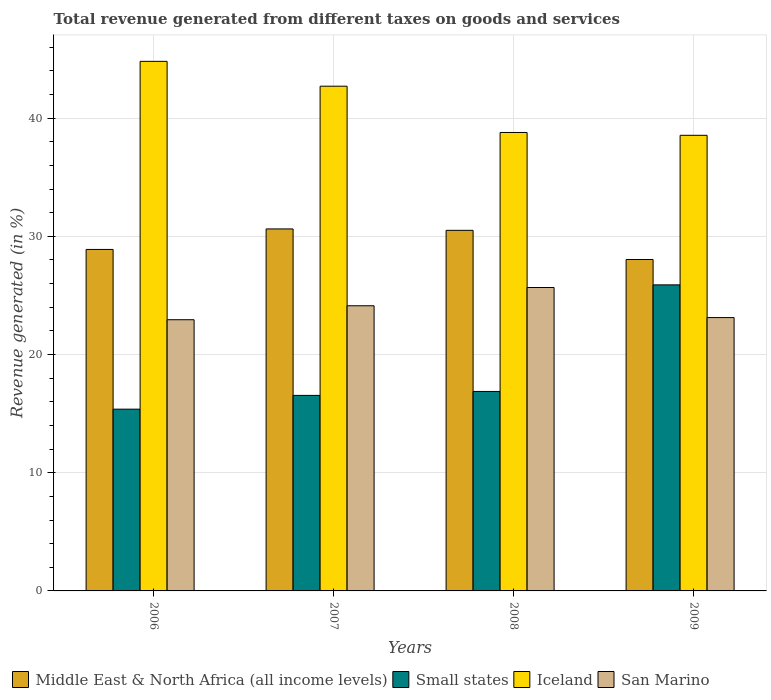How many different coloured bars are there?
Your response must be concise. 4. How many groups of bars are there?
Your answer should be very brief. 4. Are the number of bars per tick equal to the number of legend labels?
Your answer should be compact. Yes. Are the number of bars on each tick of the X-axis equal?
Your response must be concise. Yes. How many bars are there on the 3rd tick from the left?
Offer a very short reply. 4. How many bars are there on the 1st tick from the right?
Your response must be concise. 4. What is the label of the 4th group of bars from the left?
Make the answer very short. 2009. What is the total revenue generated in San Marino in 2006?
Ensure brevity in your answer.  22.95. Across all years, what is the maximum total revenue generated in Iceland?
Provide a short and direct response. 44.81. Across all years, what is the minimum total revenue generated in San Marino?
Your answer should be compact. 22.95. In which year was the total revenue generated in Iceland maximum?
Your answer should be compact. 2006. In which year was the total revenue generated in San Marino minimum?
Offer a terse response. 2006. What is the total total revenue generated in Small states in the graph?
Provide a succinct answer. 74.7. What is the difference between the total revenue generated in Iceland in 2006 and that in 2007?
Your answer should be very brief. 2.1. What is the difference between the total revenue generated in San Marino in 2008 and the total revenue generated in Small states in 2007?
Ensure brevity in your answer.  9.13. What is the average total revenue generated in Iceland per year?
Provide a short and direct response. 41.21. In the year 2006, what is the difference between the total revenue generated in Small states and total revenue generated in San Marino?
Make the answer very short. -7.57. What is the ratio of the total revenue generated in Small states in 2007 to that in 2009?
Ensure brevity in your answer.  0.64. Is the difference between the total revenue generated in Small states in 2006 and 2008 greater than the difference between the total revenue generated in San Marino in 2006 and 2008?
Keep it short and to the point. Yes. What is the difference between the highest and the second highest total revenue generated in Iceland?
Provide a succinct answer. 2.1. What is the difference between the highest and the lowest total revenue generated in Middle East & North Africa (all income levels)?
Provide a short and direct response. 2.59. Is it the case that in every year, the sum of the total revenue generated in San Marino and total revenue generated in Iceland is greater than the sum of total revenue generated in Middle East & North Africa (all income levels) and total revenue generated in Small states?
Give a very brief answer. Yes. What does the 1st bar from the left in 2009 represents?
Offer a terse response. Middle East & North Africa (all income levels). What does the 4th bar from the right in 2009 represents?
Ensure brevity in your answer.  Middle East & North Africa (all income levels). How many bars are there?
Make the answer very short. 16. How many years are there in the graph?
Offer a terse response. 4. Are the values on the major ticks of Y-axis written in scientific E-notation?
Provide a short and direct response. No. How are the legend labels stacked?
Make the answer very short. Horizontal. What is the title of the graph?
Make the answer very short. Total revenue generated from different taxes on goods and services. Does "Central Europe" appear as one of the legend labels in the graph?
Your answer should be very brief. No. What is the label or title of the X-axis?
Provide a succinct answer. Years. What is the label or title of the Y-axis?
Make the answer very short. Revenue generated (in %). What is the Revenue generated (in %) of Middle East & North Africa (all income levels) in 2006?
Provide a short and direct response. 28.89. What is the Revenue generated (in %) of Small states in 2006?
Your response must be concise. 15.38. What is the Revenue generated (in %) of Iceland in 2006?
Your response must be concise. 44.81. What is the Revenue generated (in %) of San Marino in 2006?
Provide a succinct answer. 22.95. What is the Revenue generated (in %) of Middle East & North Africa (all income levels) in 2007?
Provide a succinct answer. 30.63. What is the Revenue generated (in %) in Small states in 2007?
Your answer should be very brief. 16.54. What is the Revenue generated (in %) in Iceland in 2007?
Your response must be concise. 42.71. What is the Revenue generated (in %) of San Marino in 2007?
Your answer should be very brief. 24.13. What is the Revenue generated (in %) in Middle East & North Africa (all income levels) in 2008?
Your answer should be very brief. 30.51. What is the Revenue generated (in %) in Small states in 2008?
Provide a succinct answer. 16.88. What is the Revenue generated (in %) of Iceland in 2008?
Your answer should be compact. 38.79. What is the Revenue generated (in %) of San Marino in 2008?
Keep it short and to the point. 25.67. What is the Revenue generated (in %) of Middle East & North Africa (all income levels) in 2009?
Keep it short and to the point. 28.04. What is the Revenue generated (in %) in Small states in 2009?
Ensure brevity in your answer.  25.9. What is the Revenue generated (in %) of Iceland in 2009?
Keep it short and to the point. 38.55. What is the Revenue generated (in %) in San Marino in 2009?
Your answer should be compact. 23.13. Across all years, what is the maximum Revenue generated (in %) of Middle East & North Africa (all income levels)?
Make the answer very short. 30.63. Across all years, what is the maximum Revenue generated (in %) of Small states?
Your answer should be compact. 25.9. Across all years, what is the maximum Revenue generated (in %) of Iceland?
Provide a short and direct response. 44.81. Across all years, what is the maximum Revenue generated (in %) in San Marino?
Provide a short and direct response. 25.67. Across all years, what is the minimum Revenue generated (in %) of Middle East & North Africa (all income levels)?
Offer a very short reply. 28.04. Across all years, what is the minimum Revenue generated (in %) in Small states?
Provide a short and direct response. 15.38. Across all years, what is the minimum Revenue generated (in %) of Iceland?
Keep it short and to the point. 38.55. Across all years, what is the minimum Revenue generated (in %) of San Marino?
Your answer should be very brief. 22.95. What is the total Revenue generated (in %) in Middle East & North Africa (all income levels) in the graph?
Provide a succinct answer. 118.07. What is the total Revenue generated (in %) of Small states in the graph?
Keep it short and to the point. 74.7. What is the total Revenue generated (in %) of Iceland in the graph?
Give a very brief answer. 164.85. What is the total Revenue generated (in %) in San Marino in the graph?
Your answer should be compact. 95.87. What is the difference between the Revenue generated (in %) of Middle East & North Africa (all income levels) in 2006 and that in 2007?
Your answer should be compact. -1.74. What is the difference between the Revenue generated (in %) in Small states in 2006 and that in 2007?
Offer a very short reply. -1.16. What is the difference between the Revenue generated (in %) of Iceland in 2006 and that in 2007?
Ensure brevity in your answer.  2.1. What is the difference between the Revenue generated (in %) of San Marino in 2006 and that in 2007?
Your answer should be very brief. -1.18. What is the difference between the Revenue generated (in %) in Middle East & North Africa (all income levels) in 2006 and that in 2008?
Your response must be concise. -1.62. What is the difference between the Revenue generated (in %) of Small states in 2006 and that in 2008?
Ensure brevity in your answer.  -1.5. What is the difference between the Revenue generated (in %) in Iceland in 2006 and that in 2008?
Ensure brevity in your answer.  6.02. What is the difference between the Revenue generated (in %) of San Marino in 2006 and that in 2008?
Keep it short and to the point. -2.73. What is the difference between the Revenue generated (in %) of Middle East & North Africa (all income levels) in 2006 and that in 2009?
Provide a succinct answer. 0.85. What is the difference between the Revenue generated (in %) in Small states in 2006 and that in 2009?
Ensure brevity in your answer.  -10.52. What is the difference between the Revenue generated (in %) in Iceland in 2006 and that in 2009?
Your response must be concise. 6.26. What is the difference between the Revenue generated (in %) in San Marino in 2006 and that in 2009?
Give a very brief answer. -0.18. What is the difference between the Revenue generated (in %) in Middle East & North Africa (all income levels) in 2007 and that in 2008?
Provide a succinct answer. 0.12. What is the difference between the Revenue generated (in %) in Small states in 2007 and that in 2008?
Your answer should be very brief. -0.33. What is the difference between the Revenue generated (in %) of Iceland in 2007 and that in 2008?
Offer a terse response. 3.92. What is the difference between the Revenue generated (in %) in San Marino in 2007 and that in 2008?
Offer a terse response. -1.55. What is the difference between the Revenue generated (in %) of Middle East & North Africa (all income levels) in 2007 and that in 2009?
Offer a very short reply. 2.59. What is the difference between the Revenue generated (in %) of Small states in 2007 and that in 2009?
Offer a terse response. -9.35. What is the difference between the Revenue generated (in %) of Iceland in 2007 and that in 2009?
Your answer should be very brief. 4.16. What is the difference between the Revenue generated (in %) in Middle East & North Africa (all income levels) in 2008 and that in 2009?
Your answer should be compact. 2.47. What is the difference between the Revenue generated (in %) of Small states in 2008 and that in 2009?
Ensure brevity in your answer.  -9.02. What is the difference between the Revenue generated (in %) of Iceland in 2008 and that in 2009?
Offer a terse response. 0.24. What is the difference between the Revenue generated (in %) in San Marino in 2008 and that in 2009?
Keep it short and to the point. 2.55. What is the difference between the Revenue generated (in %) of Middle East & North Africa (all income levels) in 2006 and the Revenue generated (in %) of Small states in 2007?
Give a very brief answer. 12.35. What is the difference between the Revenue generated (in %) in Middle East & North Africa (all income levels) in 2006 and the Revenue generated (in %) in Iceland in 2007?
Ensure brevity in your answer.  -13.81. What is the difference between the Revenue generated (in %) of Middle East & North Africa (all income levels) in 2006 and the Revenue generated (in %) of San Marino in 2007?
Provide a short and direct response. 4.77. What is the difference between the Revenue generated (in %) in Small states in 2006 and the Revenue generated (in %) in Iceland in 2007?
Your answer should be very brief. -27.33. What is the difference between the Revenue generated (in %) of Small states in 2006 and the Revenue generated (in %) of San Marino in 2007?
Ensure brevity in your answer.  -8.75. What is the difference between the Revenue generated (in %) of Iceland in 2006 and the Revenue generated (in %) of San Marino in 2007?
Your answer should be compact. 20.68. What is the difference between the Revenue generated (in %) in Middle East & North Africa (all income levels) in 2006 and the Revenue generated (in %) in Small states in 2008?
Make the answer very short. 12.02. What is the difference between the Revenue generated (in %) of Middle East & North Africa (all income levels) in 2006 and the Revenue generated (in %) of Iceland in 2008?
Offer a terse response. -9.9. What is the difference between the Revenue generated (in %) in Middle East & North Africa (all income levels) in 2006 and the Revenue generated (in %) in San Marino in 2008?
Keep it short and to the point. 3.22. What is the difference between the Revenue generated (in %) of Small states in 2006 and the Revenue generated (in %) of Iceland in 2008?
Offer a very short reply. -23.41. What is the difference between the Revenue generated (in %) in Small states in 2006 and the Revenue generated (in %) in San Marino in 2008?
Offer a very short reply. -10.29. What is the difference between the Revenue generated (in %) in Iceland in 2006 and the Revenue generated (in %) in San Marino in 2008?
Provide a short and direct response. 19.14. What is the difference between the Revenue generated (in %) of Middle East & North Africa (all income levels) in 2006 and the Revenue generated (in %) of Small states in 2009?
Your response must be concise. 3. What is the difference between the Revenue generated (in %) of Middle East & North Africa (all income levels) in 2006 and the Revenue generated (in %) of Iceland in 2009?
Make the answer very short. -9.66. What is the difference between the Revenue generated (in %) in Middle East & North Africa (all income levels) in 2006 and the Revenue generated (in %) in San Marino in 2009?
Provide a succinct answer. 5.77. What is the difference between the Revenue generated (in %) of Small states in 2006 and the Revenue generated (in %) of Iceland in 2009?
Provide a short and direct response. -23.17. What is the difference between the Revenue generated (in %) of Small states in 2006 and the Revenue generated (in %) of San Marino in 2009?
Your answer should be compact. -7.75. What is the difference between the Revenue generated (in %) in Iceland in 2006 and the Revenue generated (in %) in San Marino in 2009?
Offer a very short reply. 21.68. What is the difference between the Revenue generated (in %) of Middle East & North Africa (all income levels) in 2007 and the Revenue generated (in %) of Small states in 2008?
Your response must be concise. 13.75. What is the difference between the Revenue generated (in %) in Middle East & North Africa (all income levels) in 2007 and the Revenue generated (in %) in Iceland in 2008?
Your answer should be compact. -8.16. What is the difference between the Revenue generated (in %) in Middle East & North Africa (all income levels) in 2007 and the Revenue generated (in %) in San Marino in 2008?
Your answer should be very brief. 4.96. What is the difference between the Revenue generated (in %) in Small states in 2007 and the Revenue generated (in %) in Iceland in 2008?
Make the answer very short. -22.25. What is the difference between the Revenue generated (in %) of Small states in 2007 and the Revenue generated (in %) of San Marino in 2008?
Your answer should be compact. -9.13. What is the difference between the Revenue generated (in %) of Iceland in 2007 and the Revenue generated (in %) of San Marino in 2008?
Your answer should be compact. 17.03. What is the difference between the Revenue generated (in %) of Middle East & North Africa (all income levels) in 2007 and the Revenue generated (in %) of Small states in 2009?
Ensure brevity in your answer.  4.73. What is the difference between the Revenue generated (in %) in Middle East & North Africa (all income levels) in 2007 and the Revenue generated (in %) in Iceland in 2009?
Your answer should be very brief. -7.92. What is the difference between the Revenue generated (in %) in Middle East & North Africa (all income levels) in 2007 and the Revenue generated (in %) in San Marino in 2009?
Provide a short and direct response. 7.5. What is the difference between the Revenue generated (in %) in Small states in 2007 and the Revenue generated (in %) in Iceland in 2009?
Provide a succinct answer. -22.01. What is the difference between the Revenue generated (in %) in Small states in 2007 and the Revenue generated (in %) in San Marino in 2009?
Your answer should be compact. -6.58. What is the difference between the Revenue generated (in %) of Iceland in 2007 and the Revenue generated (in %) of San Marino in 2009?
Your answer should be compact. 19.58. What is the difference between the Revenue generated (in %) of Middle East & North Africa (all income levels) in 2008 and the Revenue generated (in %) of Small states in 2009?
Give a very brief answer. 4.61. What is the difference between the Revenue generated (in %) in Middle East & North Africa (all income levels) in 2008 and the Revenue generated (in %) in Iceland in 2009?
Offer a terse response. -8.04. What is the difference between the Revenue generated (in %) of Middle East & North Africa (all income levels) in 2008 and the Revenue generated (in %) of San Marino in 2009?
Offer a very short reply. 7.38. What is the difference between the Revenue generated (in %) of Small states in 2008 and the Revenue generated (in %) of Iceland in 2009?
Make the answer very short. -21.67. What is the difference between the Revenue generated (in %) of Small states in 2008 and the Revenue generated (in %) of San Marino in 2009?
Offer a terse response. -6.25. What is the difference between the Revenue generated (in %) in Iceland in 2008 and the Revenue generated (in %) in San Marino in 2009?
Your answer should be compact. 15.66. What is the average Revenue generated (in %) of Middle East & North Africa (all income levels) per year?
Give a very brief answer. 29.52. What is the average Revenue generated (in %) of Small states per year?
Give a very brief answer. 18.67. What is the average Revenue generated (in %) of Iceland per year?
Give a very brief answer. 41.21. What is the average Revenue generated (in %) of San Marino per year?
Provide a succinct answer. 23.97. In the year 2006, what is the difference between the Revenue generated (in %) of Middle East & North Africa (all income levels) and Revenue generated (in %) of Small states?
Provide a succinct answer. 13.51. In the year 2006, what is the difference between the Revenue generated (in %) of Middle East & North Africa (all income levels) and Revenue generated (in %) of Iceland?
Ensure brevity in your answer.  -15.91. In the year 2006, what is the difference between the Revenue generated (in %) of Middle East & North Africa (all income levels) and Revenue generated (in %) of San Marino?
Your answer should be very brief. 5.95. In the year 2006, what is the difference between the Revenue generated (in %) of Small states and Revenue generated (in %) of Iceland?
Ensure brevity in your answer.  -29.43. In the year 2006, what is the difference between the Revenue generated (in %) in Small states and Revenue generated (in %) in San Marino?
Provide a succinct answer. -7.57. In the year 2006, what is the difference between the Revenue generated (in %) of Iceland and Revenue generated (in %) of San Marino?
Offer a very short reply. 21.86. In the year 2007, what is the difference between the Revenue generated (in %) in Middle East & North Africa (all income levels) and Revenue generated (in %) in Small states?
Your answer should be compact. 14.08. In the year 2007, what is the difference between the Revenue generated (in %) in Middle East & North Africa (all income levels) and Revenue generated (in %) in Iceland?
Offer a terse response. -12.08. In the year 2007, what is the difference between the Revenue generated (in %) of Middle East & North Africa (all income levels) and Revenue generated (in %) of San Marino?
Provide a short and direct response. 6.5. In the year 2007, what is the difference between the Revenue generated (in %) of Small states and Revenue generated (in %) of Iceland?
Ensure brevity in your answer.  -26.16. In the year 2007, what is the difference between the Revenue generated (in %) of Small states and Revenue generated (in %) of San Marino?
Offer a terse response. -7.58. In the year 2007, what is the difference between the Revenue generated (in %) of Iceland and Revenue generated (in %) of San Marino?
Your answer should be compact. 18.58. In the year 2008, what is the difference between the Revenue generated (in %) in Middle East & North Africa (all income levels) and Revenue generated (in %) in Small states?
Offer a terse response. 13.63. In the year 2008, what is the difference between the Revenue generated (in %) in Middle East & North Africa (all income levels) and Revenue generated (in %) in Iceland?
Your response must be concise. -8.28. In the year 2008, what is the difference between the Revenue generated (in %) in Middle East & North Africa (all income levels) and Revenue generated (in %) in San Marino?
Give a very brief answer. 4.84. In the year 2008, what is the difference between the Revenue generated (in %) of Small states and Revenue generated (in %) of Iceland?
Offer a very short reply. -21.91. In the year 2008, what is the difference between the Revenue generated (in %) of Small states and Revenue generated (in %) of San Marino?
Offer a very short reply. -8.79. In the year 2008, what is the difference between the Revenue generated (in %) of Iceland and Revenue generated (in %) of San Marino?
Your response must be concise. 13.12. In the year 2009, what is the difference between the Revenue generated (in %) of Middle East & North Africa (all income levels) and Revenue generated (in %) of Small states?
Ensure brevity in your answer.  2.15. In the year 2009, what is the difference between the Revenue generated (in %) in Middle East & North Africa (all income levels) and Revenue generated (in %) in Iceland?
Offer a very short reply. -10.51. In the year 2009, what is the difference between the Revenue generated (in %) of Middle East & North Africa (all income levels) and Revenue generated (in %) of San Marino?
Keep it short and to the point. 4.92. In the year 2009, what is the difference between the Revenue generated (in %) in Small states and Revenue generated (in %) in Iceland?
Provide a succinct answer. -12.65. In the year 2009, what is the difference between the Revenue generated (in %) in Small states and Revenue generated (in %) in San Marino?
Provide a succinct answer. 2.77. In the year 2009, what is the difference between the Revenue generated (in %) of Iceland and Revenue generated (in %) of San Marino?
Your answer should be very brief. 15.42. What is the ratio of the Revenue generated (in %) in Middle East & North Africa (all income levels) in 2006 to that in 2007?
Your response must be concise. 0.94. What is the ratio of the Revenue generated (in %) in Small states in 2006 to that in 2007?
Make the answer very short. 0.93. What is the ratio of the Revenue generated (in %) in Iceland in 2006 to that in 2007?
Make the answer very short. 1.05. What is the ratio of the Revenue generated (in %) of San Marino in 2006 to that in 2007?
Your response must be concise. 0.95. What is the ratio of the Revenue generated (in %) in Middle East & North Africa (all income levels) in 2006 to that in 2008?
Provide a succinct answer. 0.95. What is the ratio of the Revenue generated (in %) of Small states in 2006 to that in 2008?
Offer a terse response. 0.91. What is the ratio of the Revenue generated (in %) in Iceland in 2006 to that in 2008?
Your response must be concise. 1.16. What is the ratio of the Revenue generated (in %) of San Marino in 2006 to that in 2008?
Ensure brevity in your answer.  0.89. What is the ratio of the Revenue generated (in %) in Middle East & North Africa (all income levels) in 2006 to that in 2009?
Ensure brevity in your answer.  1.03. What is the ratio of the Revenue generated (in %) in Small states in 2006 to that in 2009?
Provide a short and direct response. 0.59. What is the ratio of the Revenue generated (in %) in Iceland in 2006 to that in 2009?
Ensure brevity in your answer.  1.16. What is the ratio of the Revenue generated (in %) of San Marino in 2006 to that in 2009?
Your answer should be very brief. 0.99. What is the ratio of the Revenue generated (in %) in Small states in 2007 to that in 2008?
Offer a terse response. 0.98. What is the ratio of the Revenue generated (in %) in Iceland in 2007 to that in 2008?
Make the answer very short. 1.1. What is the ratio of the Revenue generated (in %) of San Marino in 2007 to that in 2008?
Offer a very short reply. 0.94. What is the ratio of the Revenue generated (in %) of Middle East & North Africa (all income levels) in 2007 to that in 2009?
Offer a very short reply. 1.09. What is the ratio of the Revenue generated (in %) of Small states in 2007 to that in 2009?
Your answer should be very brief. 0.64. What is the ratio of the Revenue generated (in %) of Iceland in 2007 to that in 2009?
Make the answer very short. 1.11. What is the ratio of the Revenue generated (in %) in San Marino in 2007 to that in 2009?
Your answer should be compact. 1.04. What is the ratio of the Revenue generated (in %) in Middle East & North Africa (all income levels) in 2008 to that in 2009?
Ensure brevity in your answer.  1.09. What is the ratio of the Revenue generated (in %) in Small states in 2008 to that in 2009?
Keep it short and to the point. 0.65. What is the ratio of the Revenue generated (in %) in San Marino in 2008 to that in 2009?
Give a very brief answer. 1.11. What is the difference between the highest and the second highest Revenue generated (in %) in Middle East & North Africa (all income levels)?
Provide a short and direct response. 0.12. What is the difference between the highest and the second highest Revenue generated (in %) in Small states?
Ensure brevity in your answer.  9.02. What is the difference between the highest and the second highest Revenue generated (in %) of Iceland?
Keep it short and to the point. 2.1. What is the difference between the highest and the second highest Revenue generated (in %) in San Marino?
Your response must be concise. 1.55. What is the difference between the highest and the lowest Revenue generated (in %) of Middle East & North Africa (all income levels)?
Keep it short and to the point. 2.59. What is the difference between the highest and the lowest Revenue generated (in %) in Small states?
Give a very brief answer. 10.52. What is the difference between the highest and the lowest Revenue generated (in %) of Iceland?
Offer a very short reply. 6.26. What is the difference between the highest and the lowest Revenue generated (in %) in San Marino?
Your response must be concise. 2.73. 